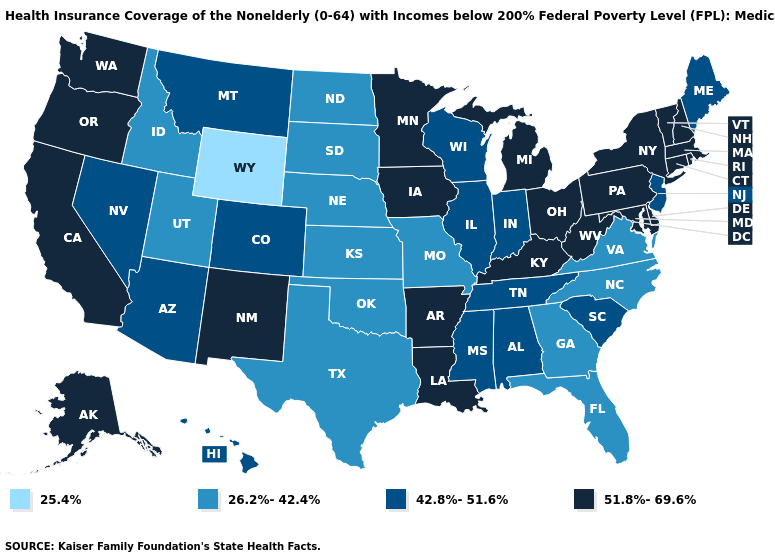What is the value of Wisconsin?
Be succinct. 42.8%-51.6%. What is the lowest value in the USA?
Write a very short answer. 25.4%. Is the legend a continuous bar?
Answer briefly. No. What is the value of Mississippi?
Concise answer only. 42.8%-51.6%. Is the legend a continuous bar?
Keep it brief. No. What is the lowest value in the South?
Write a very short answer. 26.2%-42.4%. What is the value of Michigan?
Keep it brief. 51.8%-69.6%. Is the legend a continuous bar?
Keep it brief. No. What is the lowest value in states that border Oregon?
Concise answer only. 26.2%-42.4%. Does the first symbol in the legend represent the smallest category?
Keep it brief. Yes. What is the highest value in the South ?
Be succinct. 51.8%-69.6%. Among the states that border Idaho , which have the highest value?
Be succinct. Oregon, Washington. What is the value of Florida?
Concise answer only. 26.2%-42.4%. Name the states that have a value in the range 51.8%-69.6%?
Keep it brief. Alaska, Arkansas, California, Connecticut, Delaware, Iowa, Kentucky, Louisiana, Maryland, Massachusetts, Michigan, Minnesota, New Hampshire, New Mexico, New York, Ohio, Oregon, Pennsylvania, Rhode Island, Vermont, Washington, West Virginia. Name the states that have a value in the range 26.2%-42.4%?
Concise answer only. Florida, Georgia, Idaho, Kansas, Missouri, Nebraska, North Carolina, North Dakota, Oklahoma, South Dakota, Texas, Utah, Virginia. 